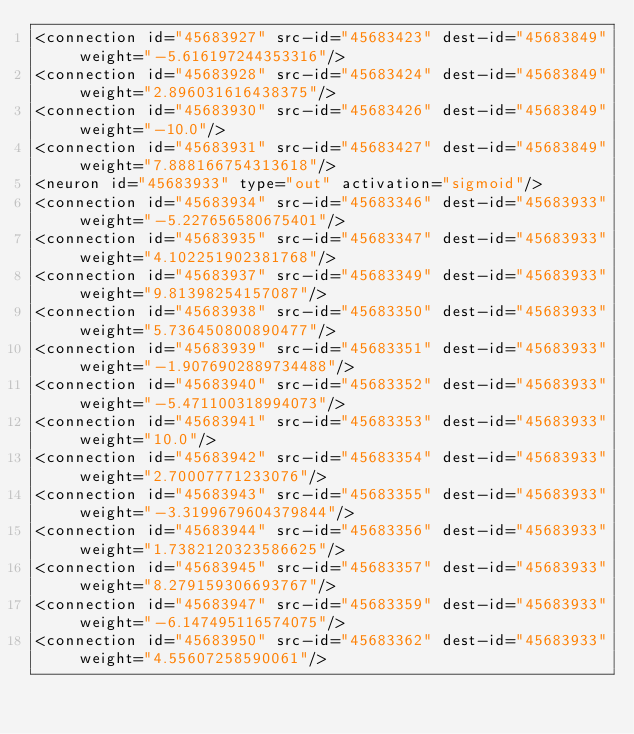<code> <loc_0><loc_0><loc_500><loc_500><_XML_><connection id="45683927" src-id="45683423" dest-id="45683849" weight="-5.616197244353316"/>
<connection id="45683928" src-id="45683424" dest-id="45683849" weight="2.896031616438375"/>
<connection id="45683930" src-id="45683426" dest-id="45683849" weight="-10.0"/>
<connection id="45683931" src-id="45683427" dest-id="45683849" weight="7.888166754313618"/>
<neuron id="45683933" type="out" activation="sigmoid"/>
<connection id="45683934" src-id="45683346" dest-id="45683933" weight="-5.227656580675401"/>
<connection id="45683935" src-id="45683347" dest-id="45683933" weight="4.102251902381768"/>
<connection id="45683937" src-id="45683349" dest-id="45683933" weight="9.81398254157087"/>
<connection id="45683938" src-id="45683350" dest-id="45683933" weight="5.736450800890477"/>
<connection id="45683939" src-id="45683351" dest-id="45683933" weight="-1.9076902889734488"/>
<connection id="45683940" src-id="45683352" dest-id="45683933" weight="-5.471100318994073"/>
<connection id="45683941" src-id="45683353" dest-id="45683933" weight="10.0"/>
<connection id="45683942" src-id="45683354" dest-id="45683933" weight="2.70007771233076"/>
<connection id="45683943" src-id="45683355" dest-id="45683933" weight="-3.3199679604379844"/>
<connection id="45683944" src-id="45683356" dest-id="45683933" weight="1.7382120323586625"/>
<connection id="45683945" src-id="45683357" dest-id="45683933" weight="8.279159306693767"/>
<connection id="45683947" src-id="45683359" dest-id="45683933" weight="-6.147495116574075"/>
<connection id="45683950" src-id="45683362" dest-id="45683933" weight="4.55607258590061"/></code> 